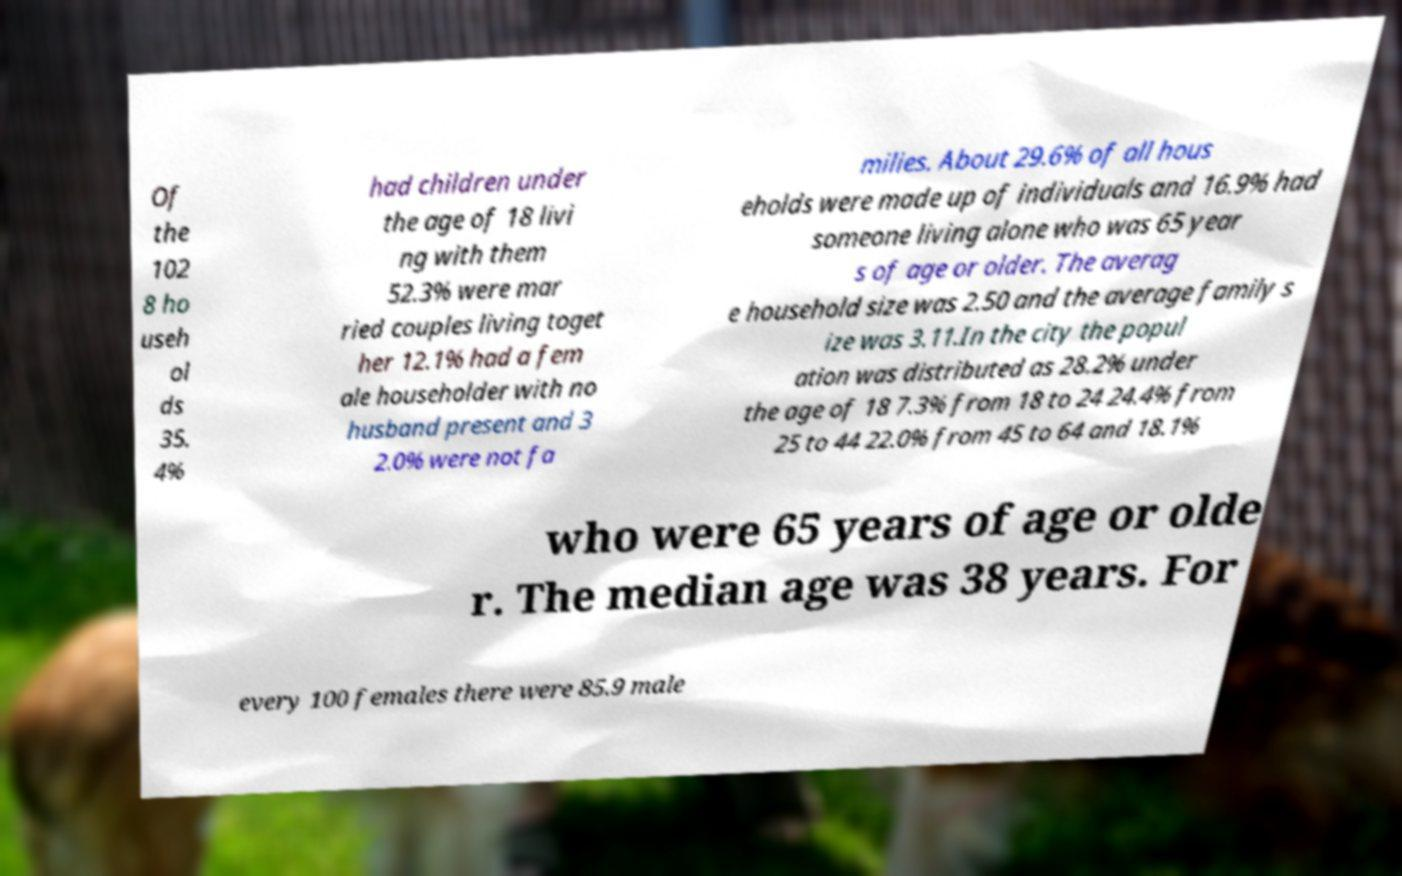Can you accurately transcribe the text from the provided image for me? Of the 102 8 ho useh ol ds 35. 4% had children under the age of 18 livi ng with them 52.3% were mar ried couples living toget her 12.1% had a fem ale householder with no husband present and 3 2.0% were not fa milies. About 29.6% of all hous eholds were made up of individuals and 16.9% had someone living alone who was 65 year s of age or older. The averag e household size was 2.50 and the average family s ize was 3.11.In the city the popul ation was distributed as 28.2% under the age of 18 7.3% from 18 to 24 24.4% from 25 to 44 22.0% from 45 to 64 and 18.1% who were 65 years of age or olde r. The median age was 38 years. For every 100 females there were 85.9 male 